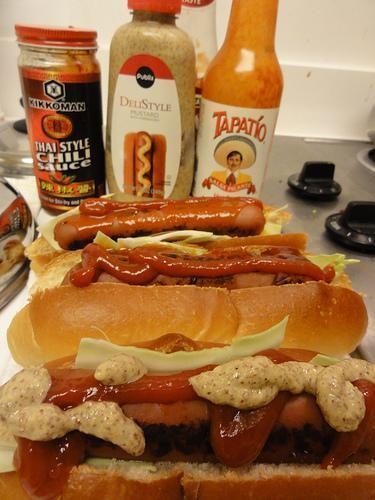How many condiments are there?
Give a very brief answer. 3. How many hotdogs have mustard on them?
Give a very brief answer. 1. 